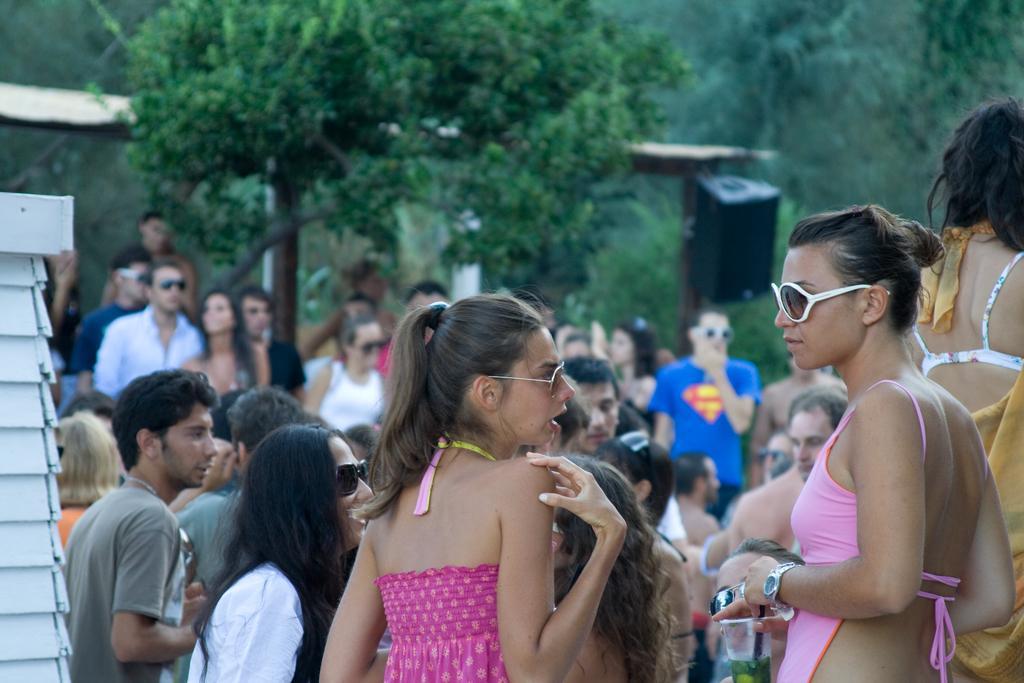Could you give a brief overview of what you see in this image? In this image there are two persons with spectacles are standing , and in the background there are group of people standing, trees, speaker. 